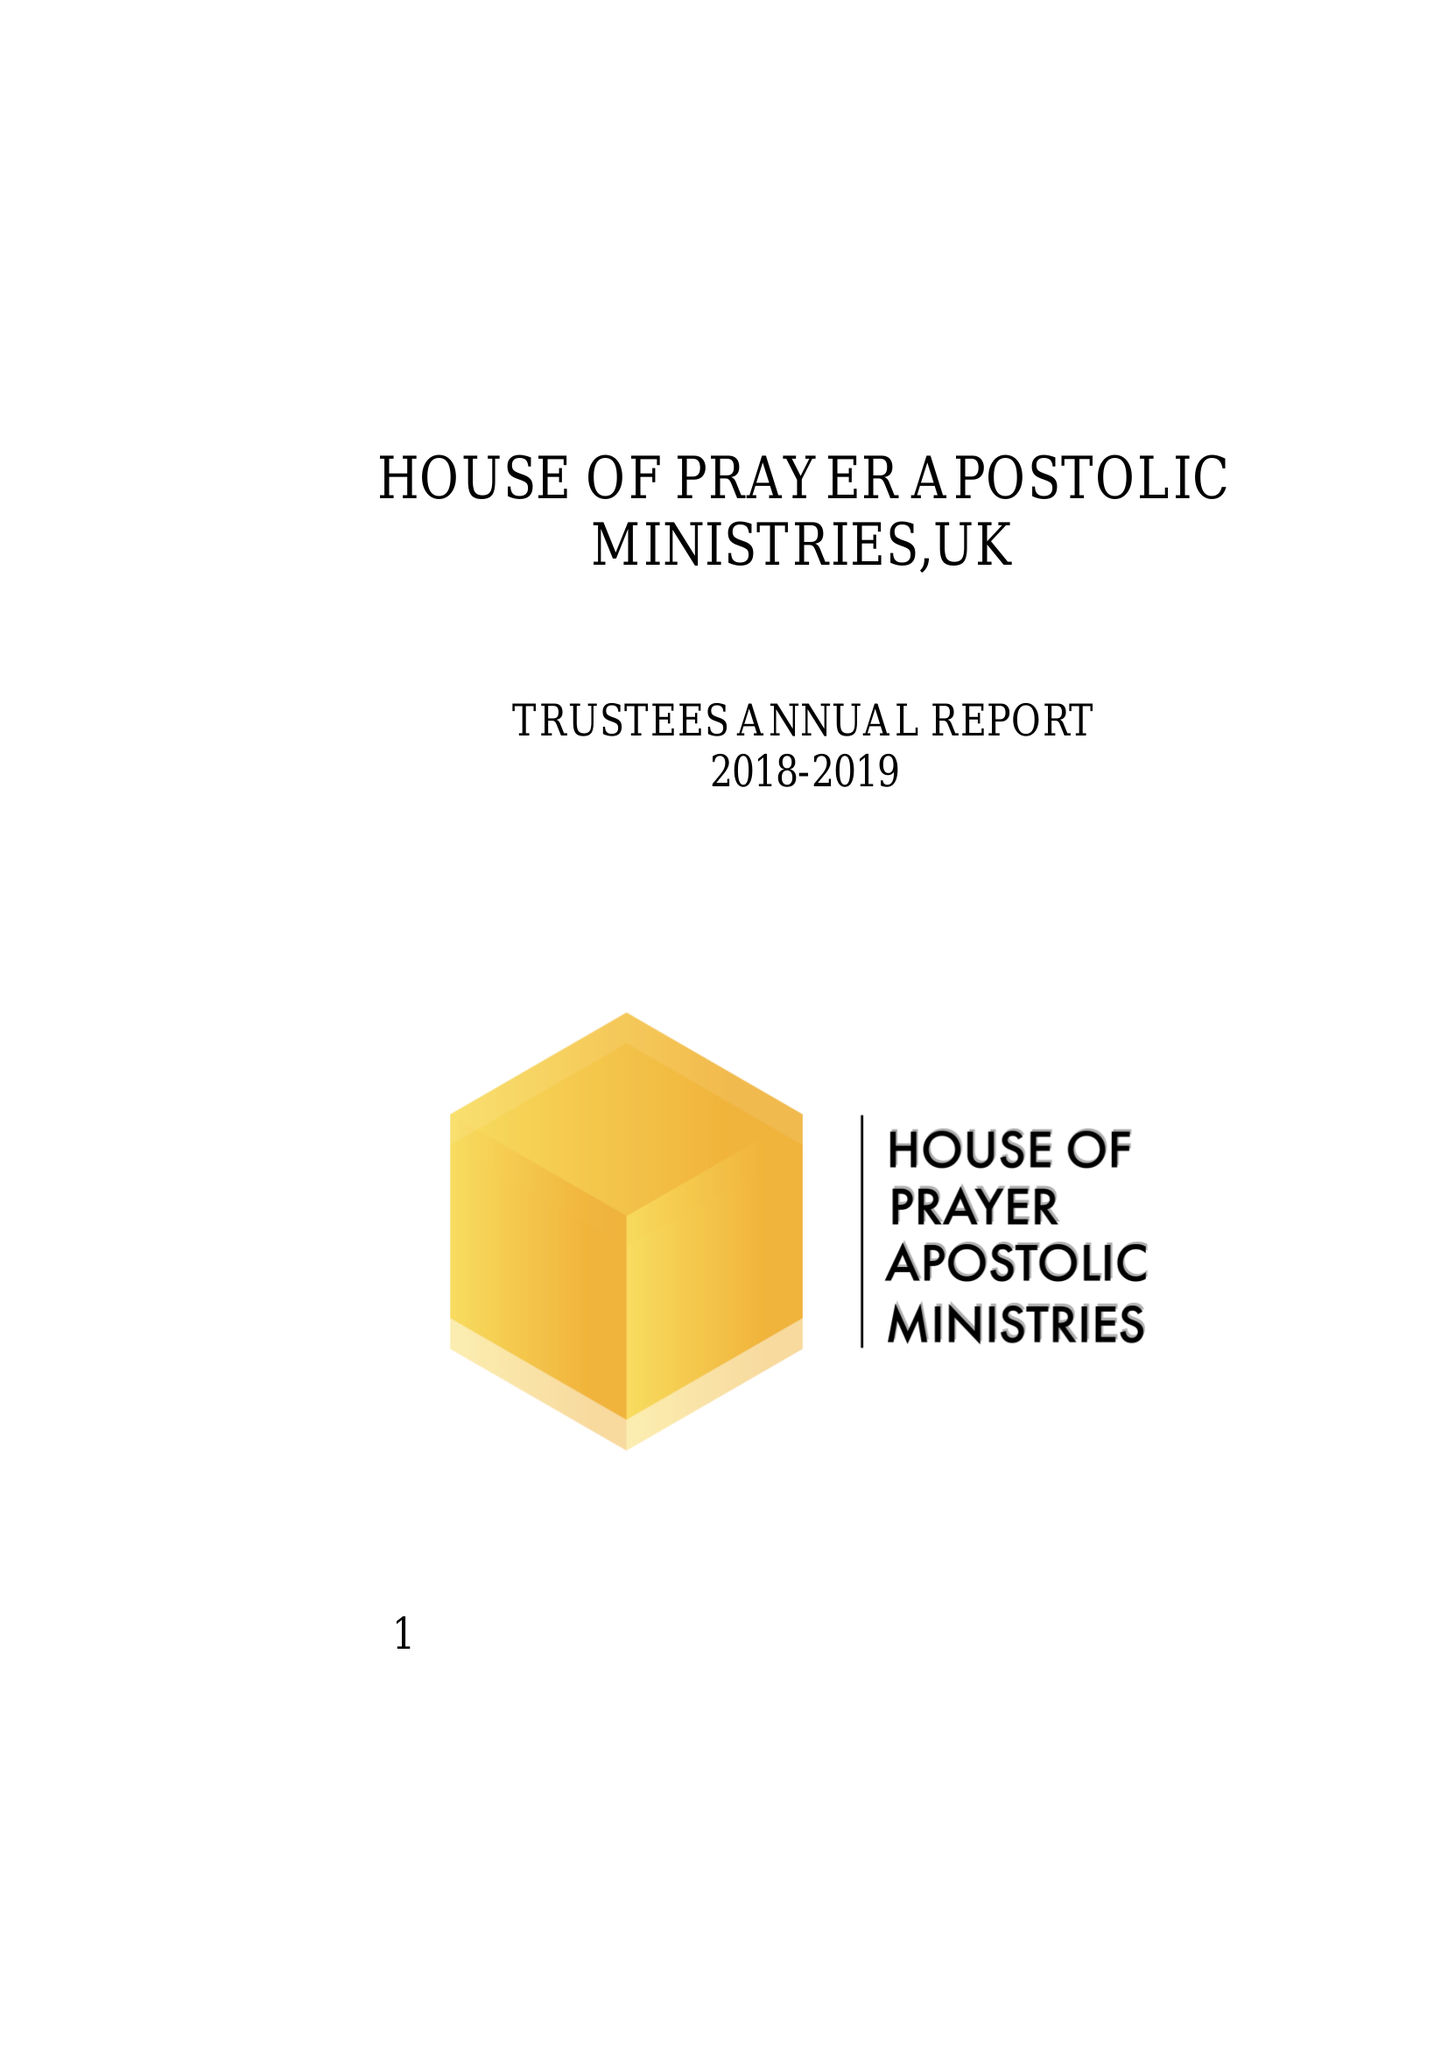What is the value for the charity_name?
Answer the question using a single word or phrase. House Of Prayer Apostolic Ministries 